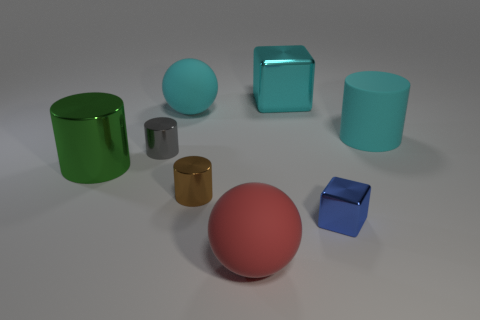There is a cyan object that is the same shape as the big red rubber thing; what is its size?
Make the answer very short. Large. How many small cylinders are there?
Provide a succinct answer. 2. Does the blue metallic thing have the same shape as the large matte object that is right of the tiny blue shiny thing?
Your response must be concise. No. There is a object that is in front of the small blue metallic block; how big is it?
Provide a short and direct response. Large. What material is the blue object?
Offer a very short reply. Metal. Does the cyan rubber object on the left side of the small brown metal thing have the same shape as the big red matte object?
Ensure brevity in your answer.  Yes. What size is the ball that is the same color as the matte cylinder?
Provide a succinct answer. Large. Are there any green rubber cylinders of the same size as the gray object?
Offer a terse response. No. There is a big rubber sphere that is left of the large rubber thing in front of the gray object; are there any gray cylinders on the right side of it?
Your answer should be very brief. No. Do the big shiny block and the big cylinder that is to the left of the big cyan metal object have the same color?
Provide a succinct answer. No. 